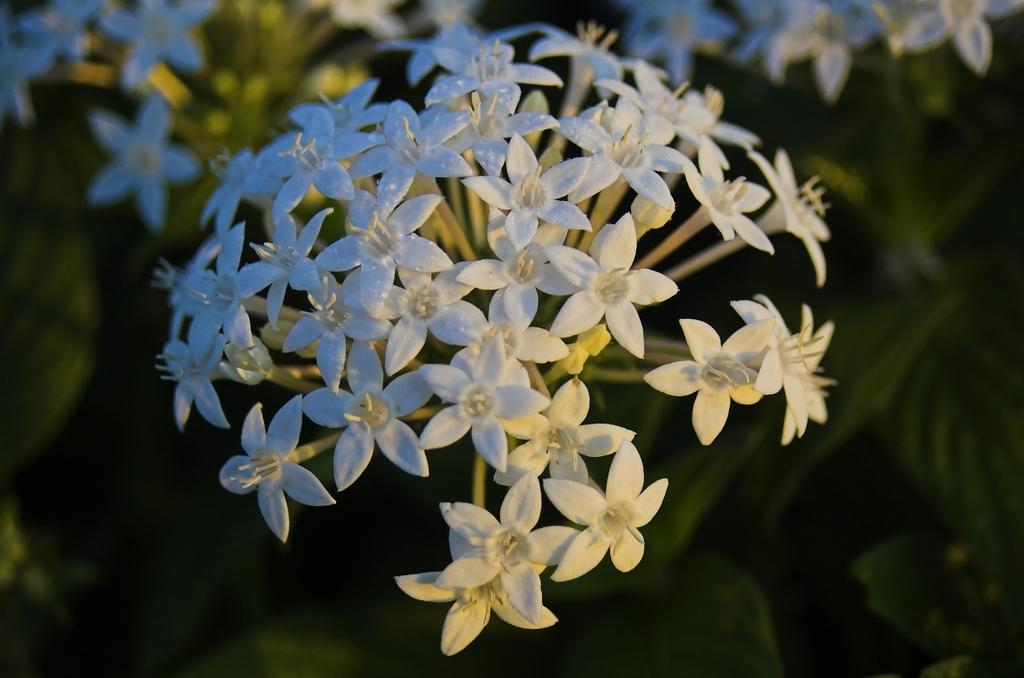What type of living organisms can be seen in the image? Plants can be seen in the image. What color are the flowers on the plants in the image? The flowers on the plants in the image are white. What type of print can be seen on the baseball uniform in the image? There is no baseball uniform or print present in the image; it features plants with white flowers. 